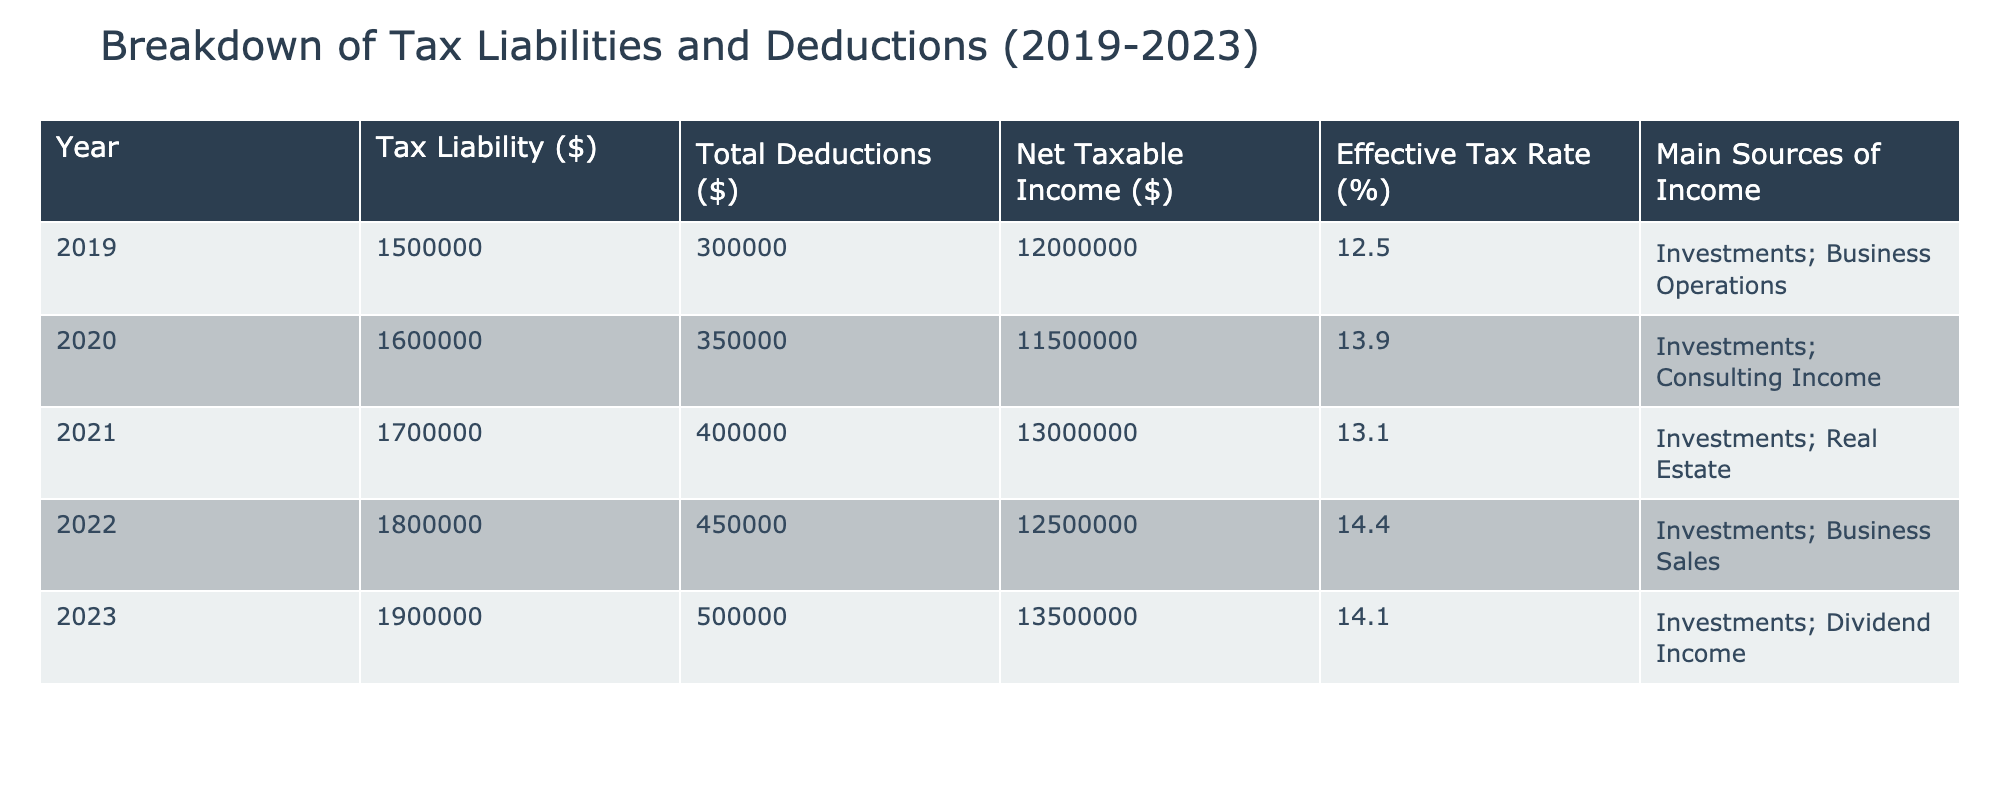What was the highest tax liability recorded during the five years? The highest tax liability can be found by looking at the "Tax Liability ($)" column of the table. The values for each year are: 2019 - 1,500,000; 2020 - 1,600,000; 2021 - 1,700,000; 2022 - 1,800,000; and 2023 - 1,900,000. The highest value is 1,900,000 for the year 2023.
Answer: 1,900,000 What is the average effective tax rate over the five years? To find the average effective tax rate, sum the values from the "Effective Tax Rate (%)" column: 12.5 + 13.9 + 13.1 + 14.4 + 14.1 = 68.0. Then divide by the number of years (5): 68.0 / 5 = 13.6.
Answer: 13.6 Was there an increase in total deductions from 2019 to 2023? By comparing the "Total Deductions ($)" column, 2019 shows 300,000 and 2023 shows 500,000. Since 500,000 is greater than 300,000, this indicates an increase.
Answer: Yes What percentage did tax liability increase from 2019 to 2023? The tax liability increased from 1,500,000 in 2019 to 1,900,000 in 2023. The difference is 1,900,000 - 1,500,000 = 400,000. To find the percentage increase, divide the difference by the original amount: (400,000 / 1,500,000) * 100 = 26.67%.
Answer: 26.67% Which year had the lowest net taxable income? The net taxable income for each year is: 2019 - 12,000,000; 2020 - 11,500,000; 2021 - 13,000,000; 2022 - 12,500,000; and 2023 - 13,500,000. The lowest value is 11,500,000 for the year 2020.
Answer: 2020 What was the total tax liability accumulated over the five years? To find the total tax liability, sum the values from the "Tax Liability ($)" column: 1,500,000 + 1,600,000 + 1,700,000 + 1,800,000 + 1,900,000 = 8,500,000.
Answer: 8,500,000 Is the main source of income consistent across the five years? Checking the "Main Sources of Income" column reveals variations: 2019 - Investments; Business Operations; 2020 - Investments; Consulting Income; 2021 - Investments; Real Estate; 2022 - Investments; Business Sales; 2023 - Investments; Dividend Income. Since the main sources change each year, they are not consistent.
Answer: No In which year did the effective tax rate exceed 14%? The effective tax rates for each year are: 2019 - 12.5; 2020 - 13.9; 2021 - 13.1; 2022 - 14.4; and 2023 - 14.1. The years that exceed 14% are 2022 and 2023.
Answer: 2022 and 2023 